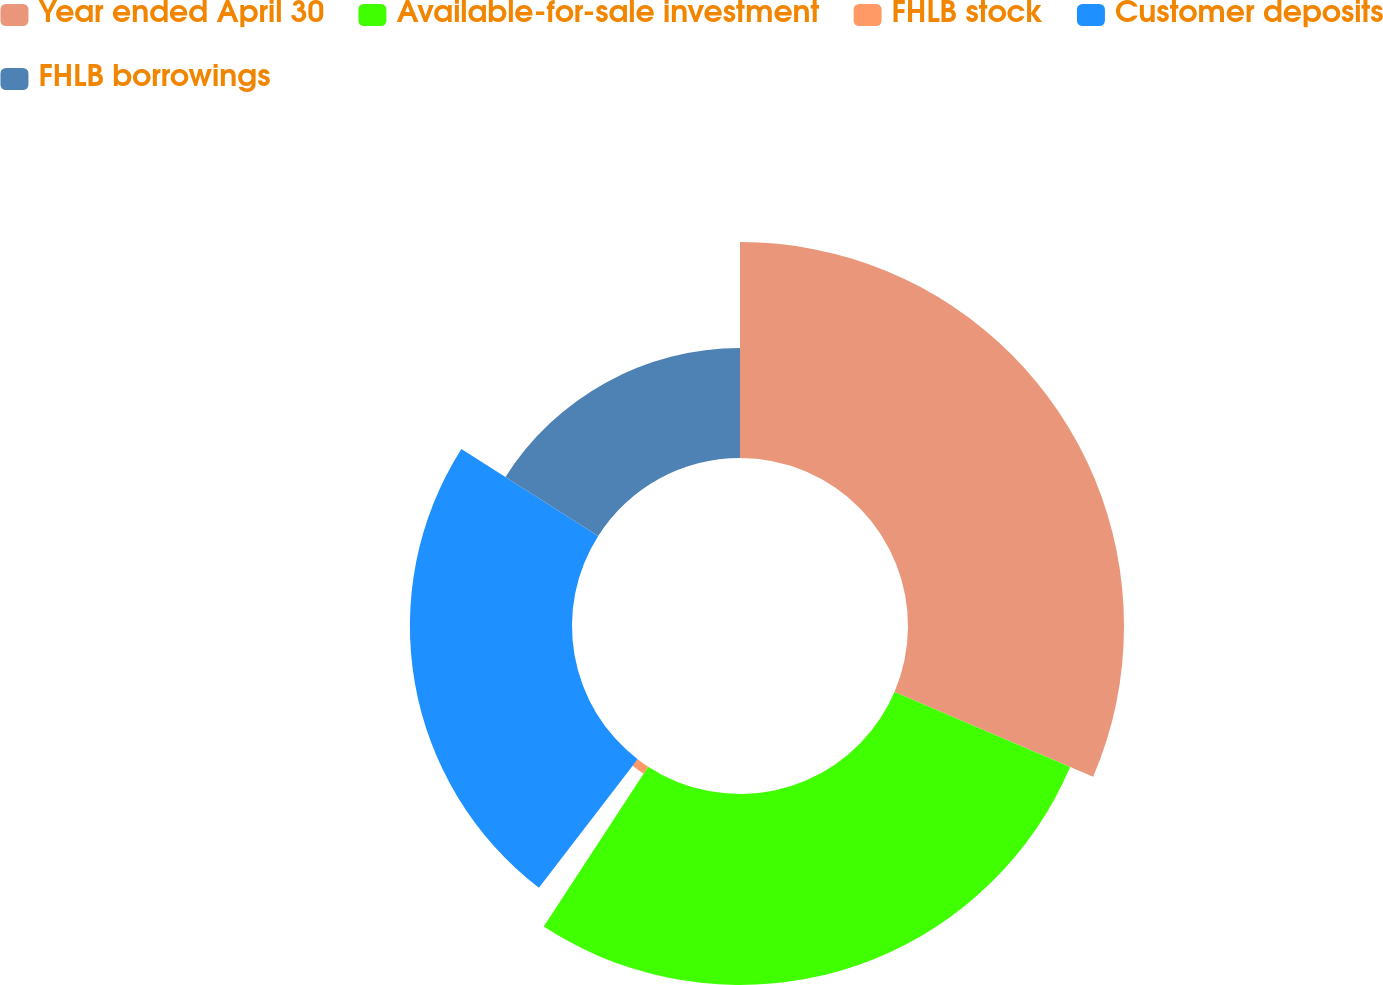Convert chart to OTSL. <chart><loc_0><loc_0><loc_500><loc_500><pie_chart><fcel>Year ended April 30<fcel>Available-for-sale investment<fcel>FHLB stock<fcel>Customer deposits<fcel>FHLB borrowings<nl><fcel>31.42%<fcel>27.78%<fcel>1.22%<fcel>23.58%<fcel>15.99%<nl></chart> 